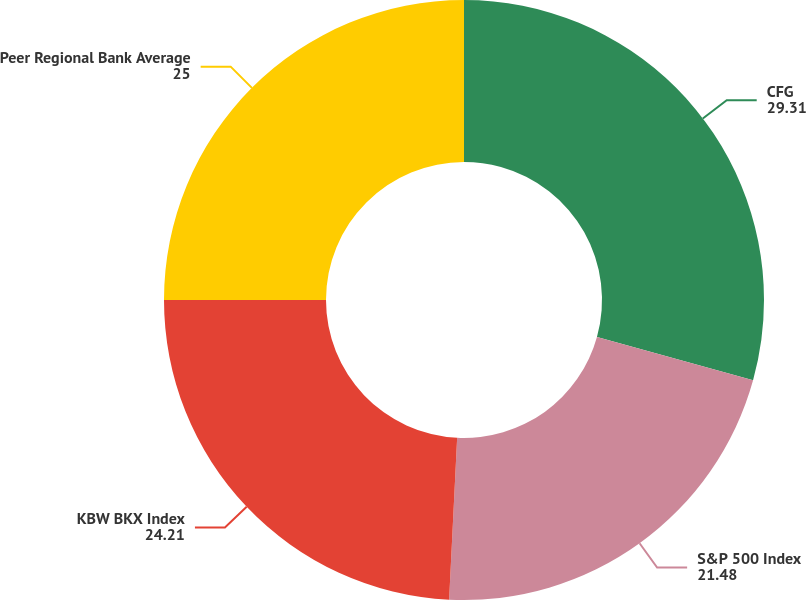<chart> <loc_0><loc_0><loc_500><loc_500><pie_chart><fcel>CFG<fcel>S&P 500 Index<fcel>KBW BKX Index<fcel>Peer Regional Bank Average<nl><fcel>29.31%<fcel>21.48%<fcel>24.21%<fcel>25.0%<nl></chart> 